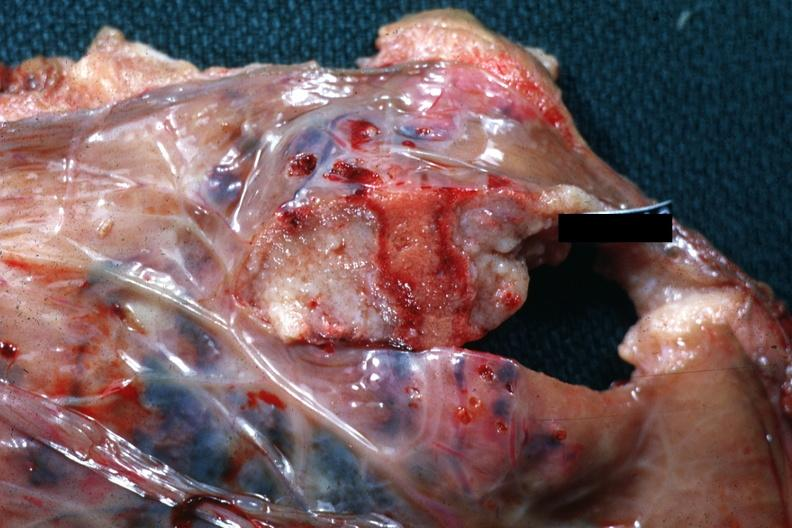what does this image show?
Answer the question using a single word or phrase. Good close-up of needle tract with necrotic center 